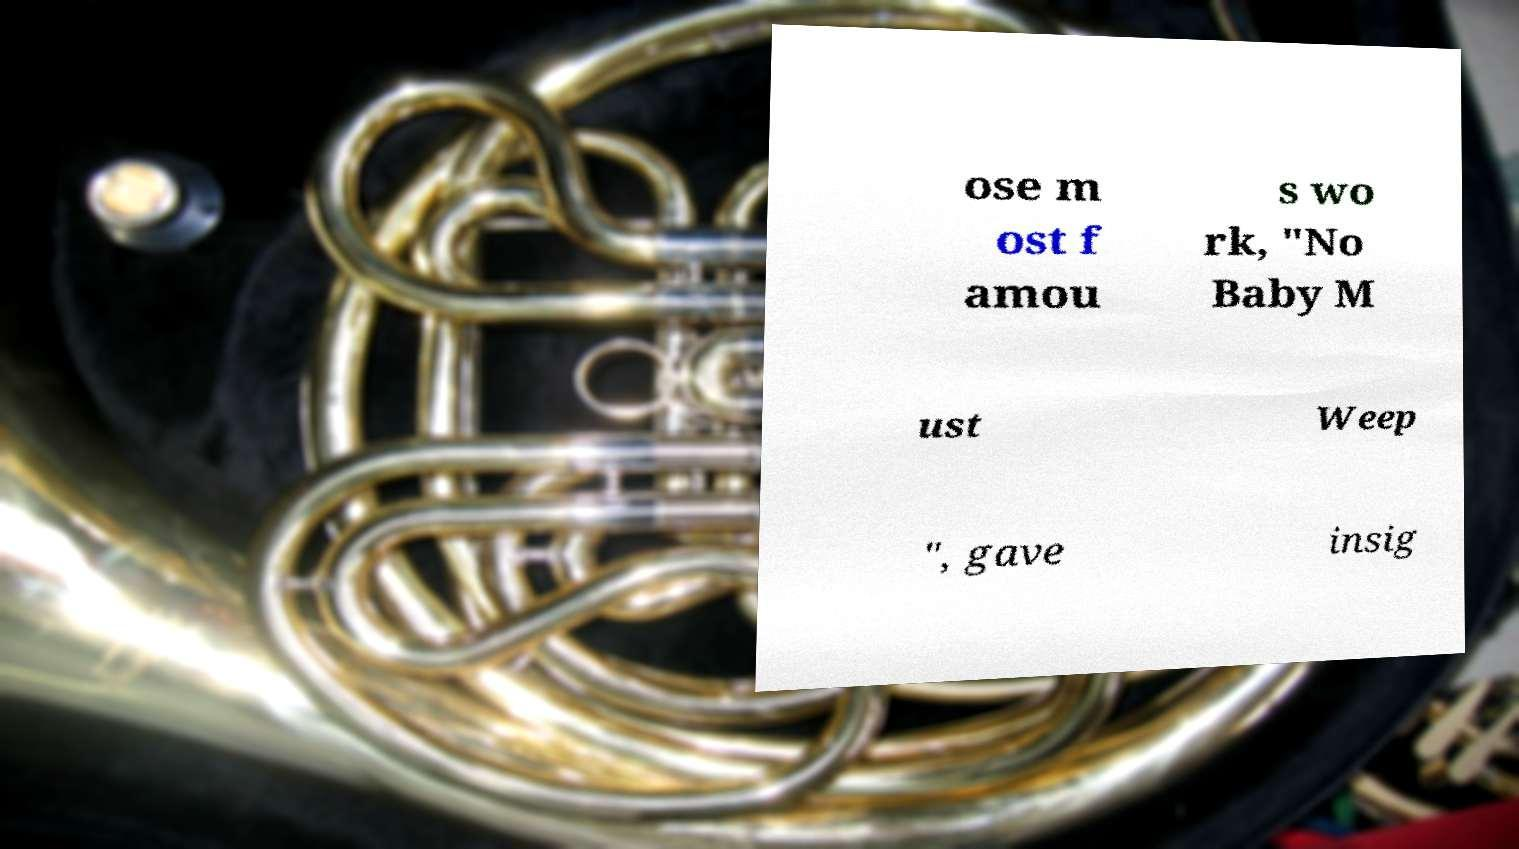Please identify and transcribe the text found in this image. ose m ost f amou s wo rk, "No Baby M ust Weep ", gave insig 